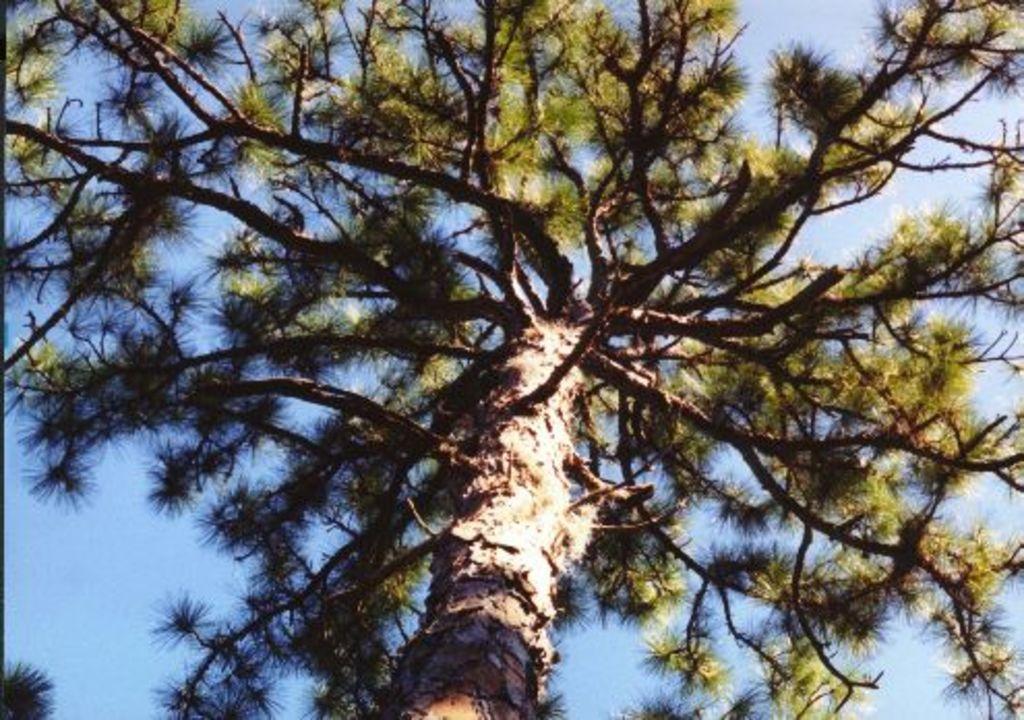Describe this image in one or two sentences. This image consists of a tree along with green leaves. In the background there is sky. 